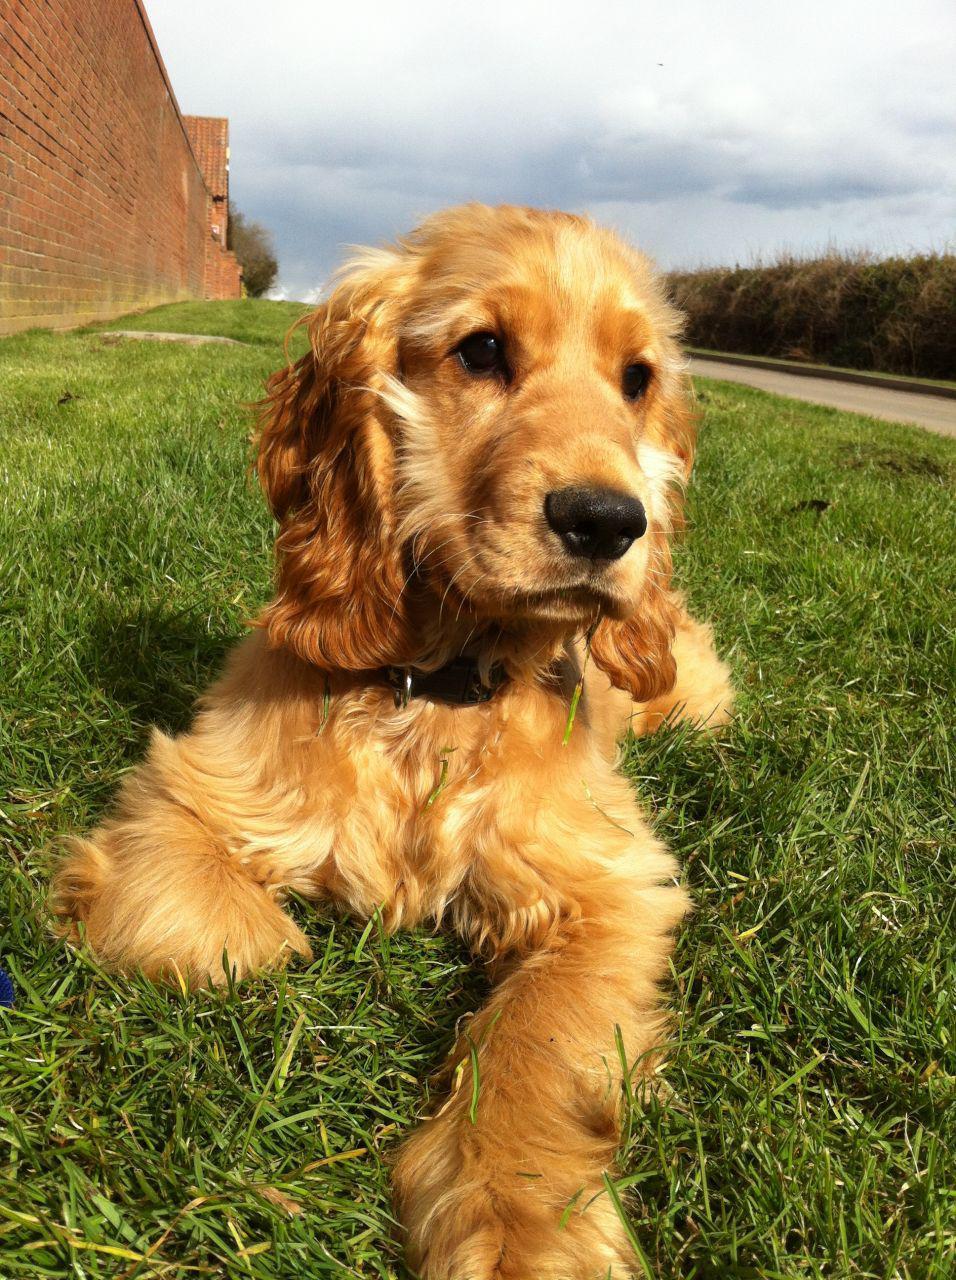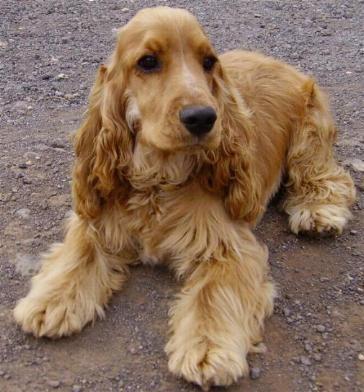The first image is the image on the left, the second image is the image on the right. Given the left and right images, does the statement "The dogs in the image on the right are not on grass." hold true? Answer yes or no. Yes. 